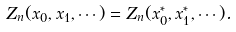<formula> <loc_0><loc_0><loc_500><loc_500>Z _ { n } ( x _ { 0 } , x _ { 1 } , \cdots ) = Z _ { n } ( x ^ { * } _ { 0 } , x ^ { * } _ { 1 } , \cdots ) .</formula> 